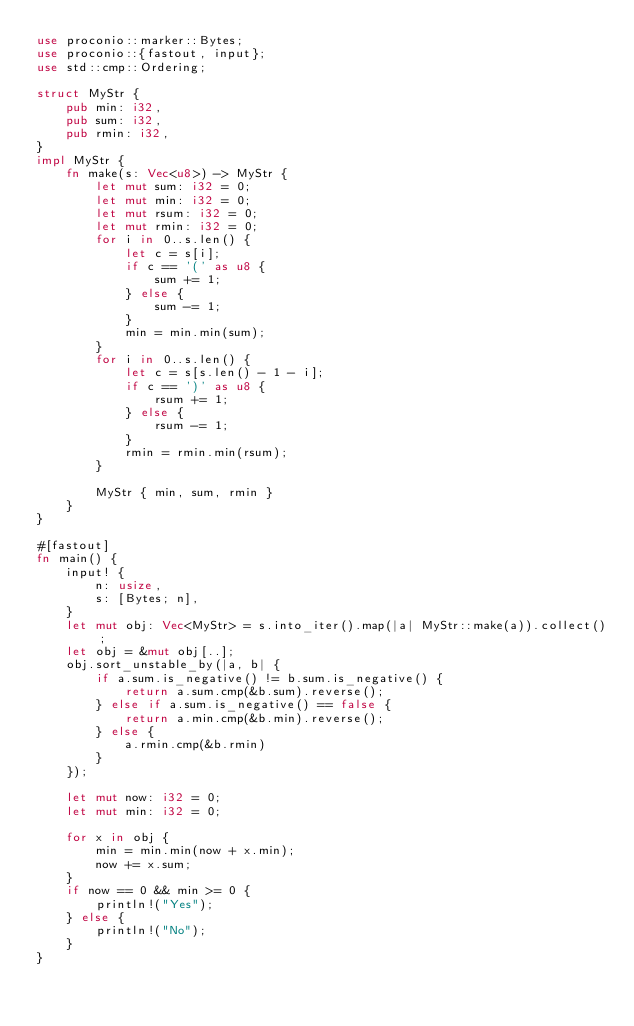<code> <loc_0><loc_0><loc_500><loc_500><_Rust_>use proconio::marker::Bytes;
use proconio::{fastout, input};
use std::cmp::Ordering;

struct MyStr {
    pub min: i32,
    pub sum: i32,
    pub rmin: i32,
}
impl MyStr {
    fn make(s: Vec<u8>) -> MyStr {
        let mut sum: i32 = 0;
        let mut min: i32 = 0;
        let mut rsum: i32 = 0;
        let mut rmin: i32 = 0;
        for i in 0..s.len() {
            let c = s[i];
            if c == '(' as u8 {
                sum += 1;
            } else {
                sum -= 1;
            }
            min = min.min(sum);
        }
        for i in 0..s.len() {
            let c = s[s.len() - 1 - i];
            if c == ')' as u8 {
                rsum += 1;
            } else {
                rsum -= 1;
            }
            rmin = rmin.min(rsum);
        }

        MyStr { min, sum, rmin }
    }
}

#[fastout]
fn main() {
    input! {
        n: usize,
        s: [Bytes; n],
    }
    let mut obj: Vec<MyStr> = s.into_iter().map(|a| MyStr::make(a)).collect();
    let obj = &mut obj[..];
    obj.sort_unstable_by(|a, b| {
        if a.sum.is_negative() != b.sum.is_negative() {
            return a.sum.cmp(&b.sum).reverse();
        } else if a.sum.is_negative() == false {
            return a.min.cmp(&b.min).reverse();
        } else {
            a.rmin.cmp(&b.rmin)
        }
    });

    let mut now: i32 = 0;
    let mut min: i32 = 0;

    for x in obj {
        min = min.min(now + x.min);
        now += x.sum;
    }
    if now == 0 && min >= 0 {
        println!("Yes");
    } else {
        println!("No");
    }
}
</code> 